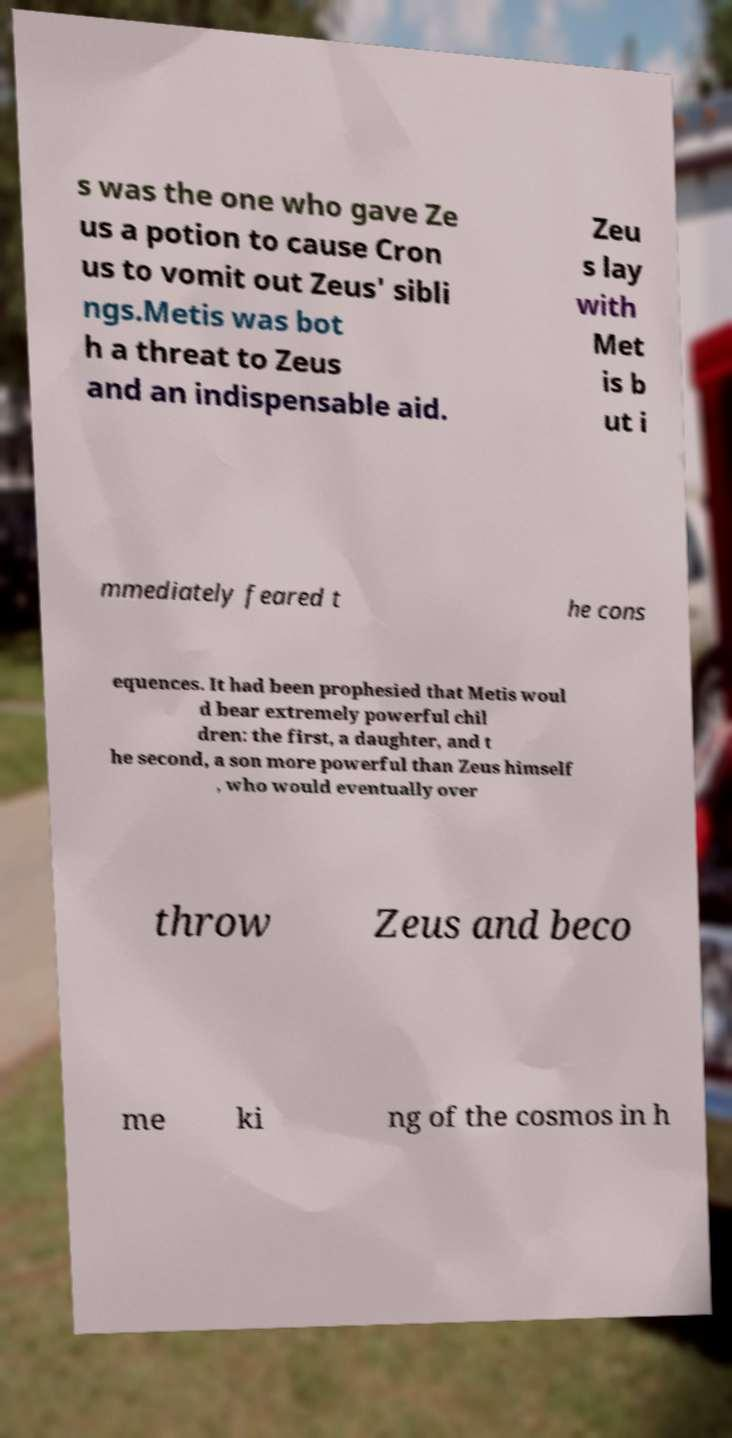Could you extract and type out the text from this image? s was the one who gave Ze us a potion to cause Cron us to vomit out Zeus' sibli ngs.Metis was bot h a threat to Zeus and an indispensable aid. Zeu s lay with Met is b ut i mmediately feared t he cons equences. It had been prophesied that Metis woul d bear extremely powerful chil dren: the first, a daughter, and t he second, a son more powerful than Zeus himself , who would eventually over throw Zeus and beco me ki ng of the cosmos in h 